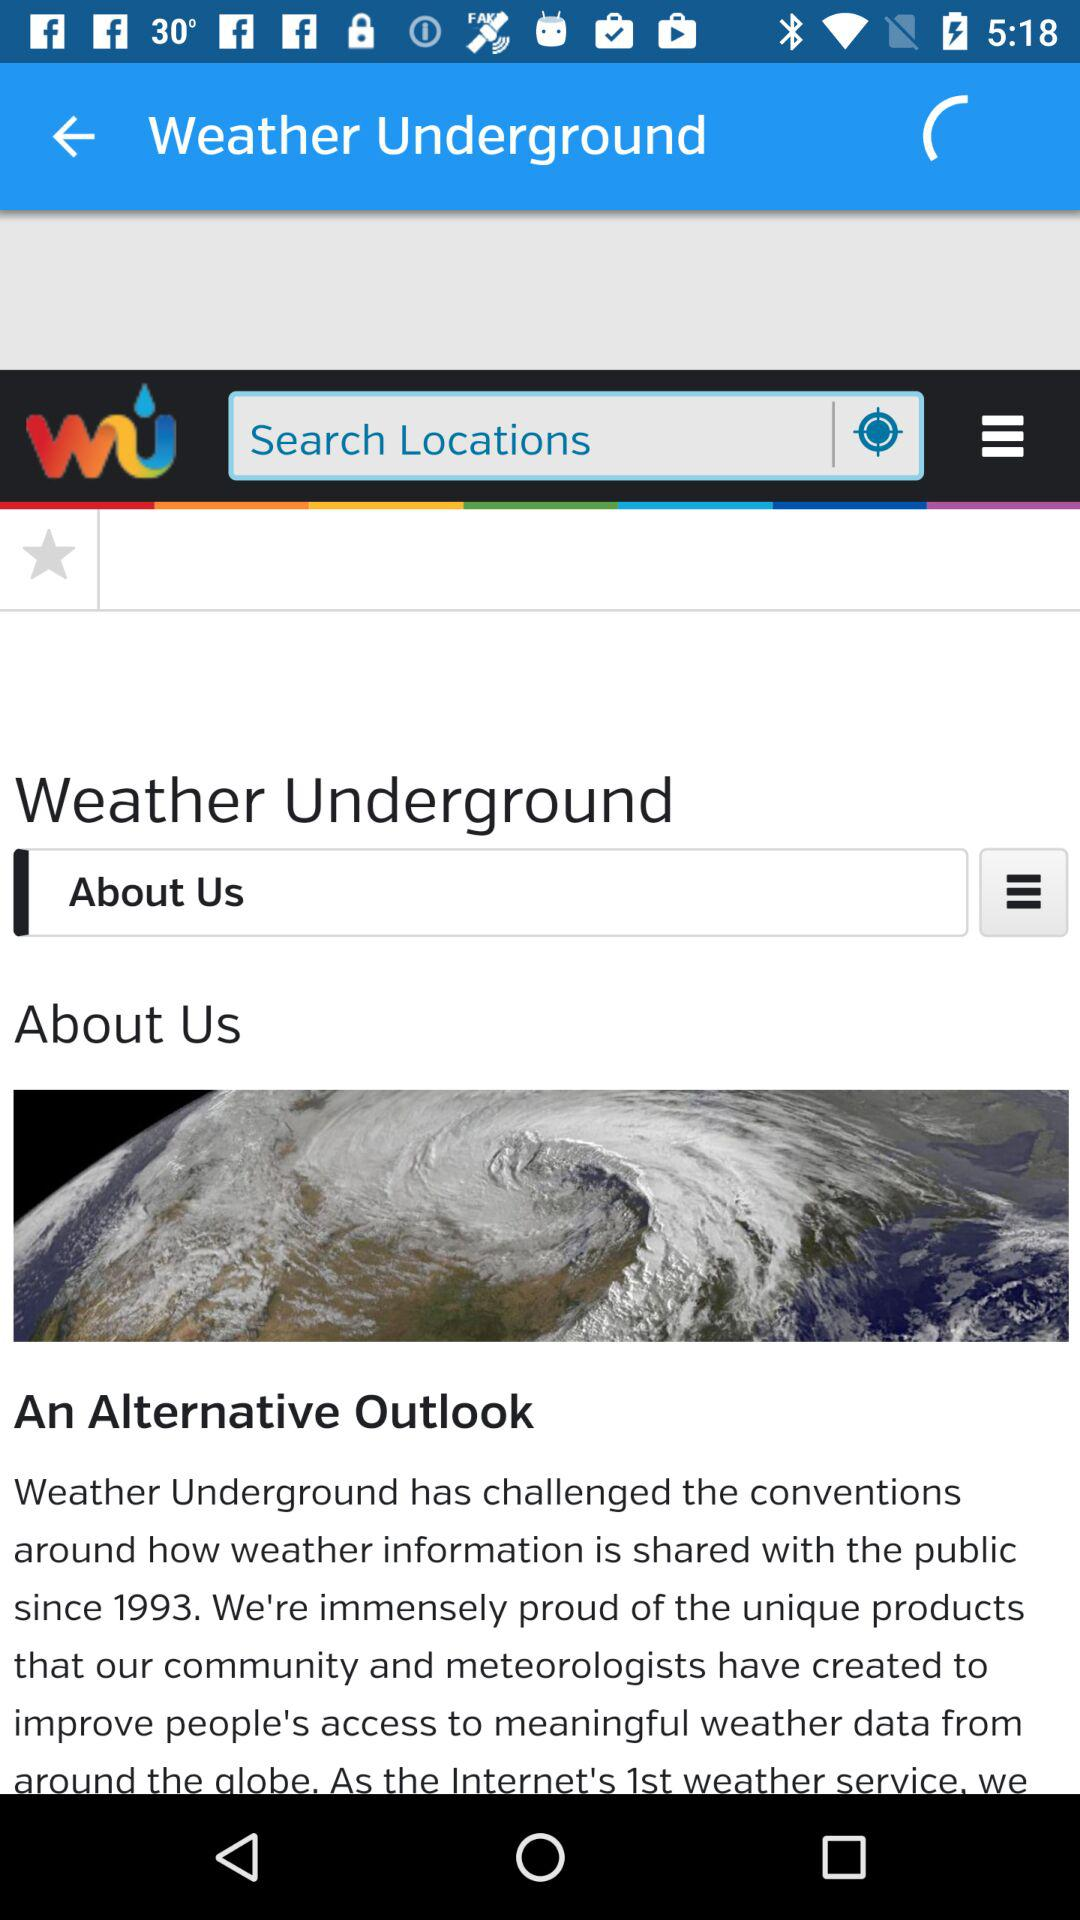What is the name of the application? The name of the application is "Weather Underground". 